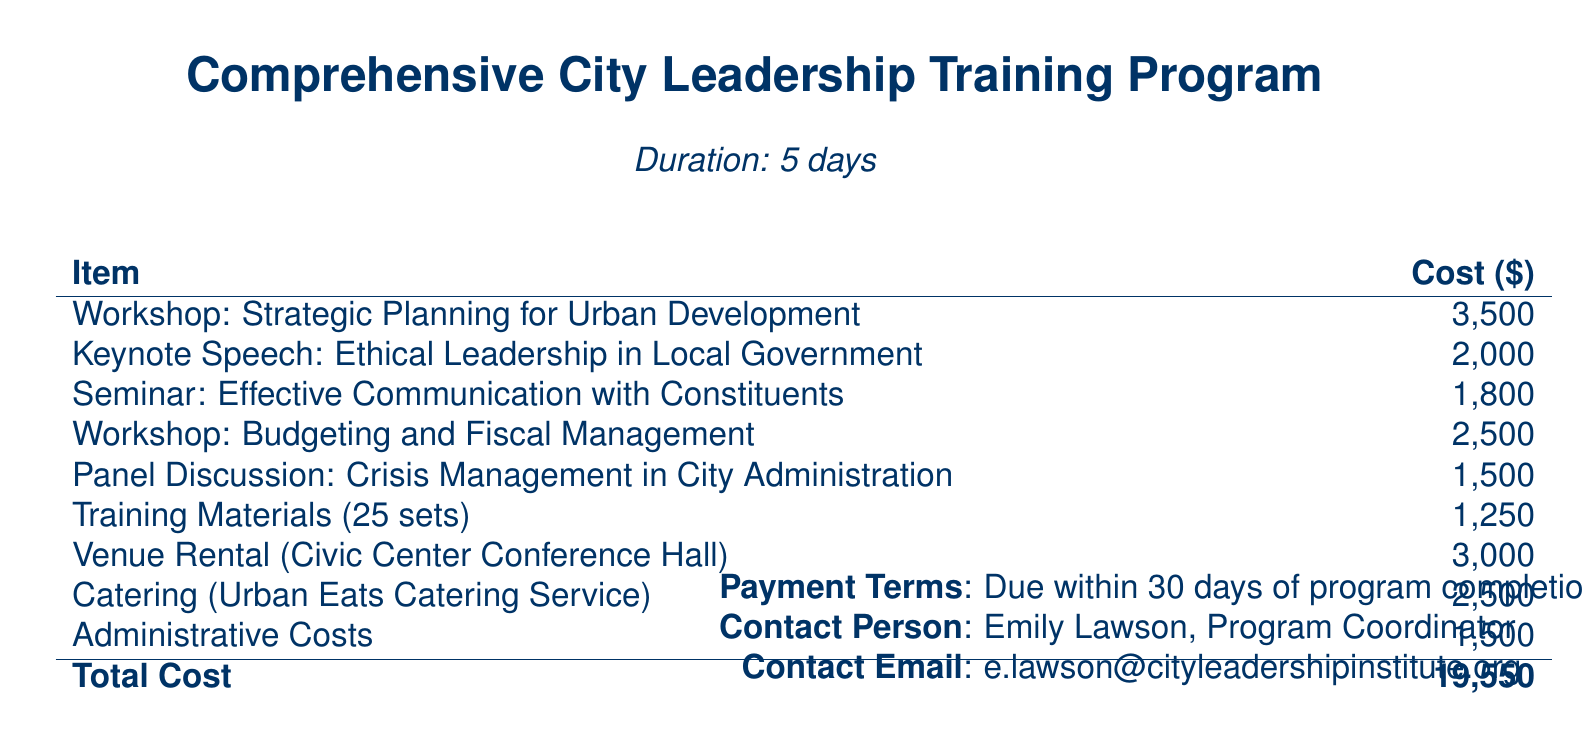what is the duration of the training program? The duration is explicitly stated in the document as "5 days."
Answer: 5 days who is the contact person for this program? The document lists Emily Lawson as the Program Coordinator.
Answer: Emily Lawson what is the cost of the seminar on effective communication? The cost is provided in the table and is $1,800.
Answer: 1,800 how much will the venue rental cost? The document specifies the venue rental cost as $3,000.
Answer: 3,000 what is the total cost of the comprehensive city leadership training program? The total cost is summed up at the bottom of the table as $19,550.
Answer: 19,550 which workshop has the highest cost? The highest cost workshop is "Strategic Planning for Urban Development" at $3,500.
Answer: Strategic Planning for Urban Development what are the payment terms? The document clearly states that payment is due within 30 days of program completion.
Answer: Due within 30 days of program completion how many sets of training materials are included? The document indicates that there are 25 sets of training materials included.
Answer: 25 sets 